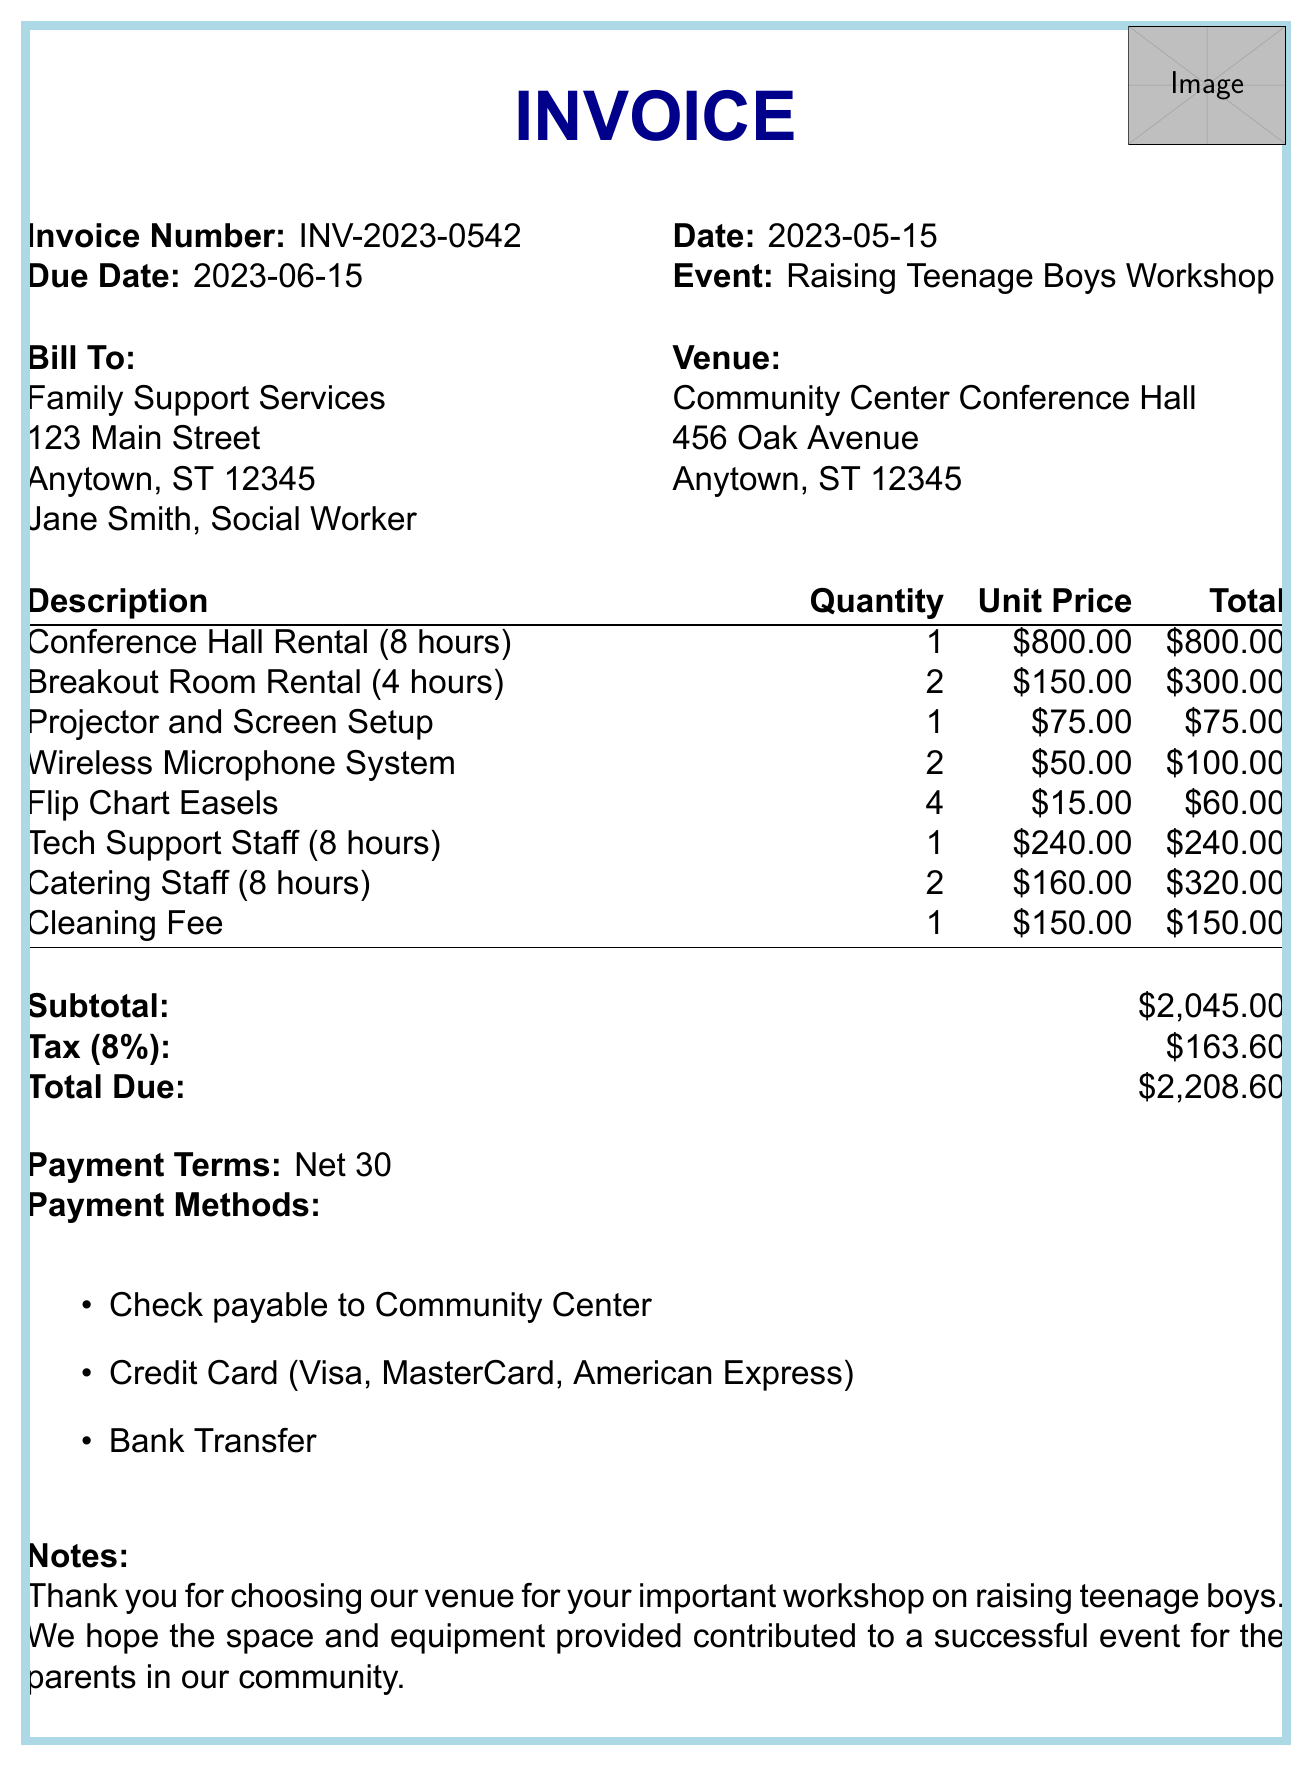What is the invoice number? The invoice number is mentioned at the top of the document as a unique identifier for this transaction.
Answer: INV-2023-0542 What is the due date for the invoice? The due date is specified in the document, indicating when the payment should be made.
Answer: 2023-06-15 What is the total due amount? The total due amount is calculated at the bottom of the invoice and represents the final amount owed.
Answer: $2208.60 How many hours was the Conference Hall rented? The document specifies the rental duration for the Conference Hall within the description of the line items.
Answer: 8 hours Who is the contact person for the billing? The document includes the name and title of the billing contact for the organization.
Answer: Jane Smith, Social Worker What is the subtotal for the services before tax? The subtotal is listed in the document as the sum of all line items before tax is applied.
Answer: $2045.00 How many breakout rooms were rented? The number of breakout rooms rented is indicated in the line items section of the invoice.
Answer: 2 What percentage is the tax applied? The tax rate is noted in the document, representing the percentage of tax calculated on the subtotal.
Answer: 8% What are the payment methods accepted? The accepted payment methods are listed and provide options for how to settle the invoice.
Answer: Check payable to Community Center, Credit Card (Visa, MasterCard, American Express), Bank Transfer 